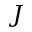<formula> <loc_0><loc_0><loc_500><loc_500>J</formula> 